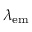Convert formula to latex. <formula><loc_0><loc_0><loc_500><loc_500>\lambda _ { e m }</formula> 